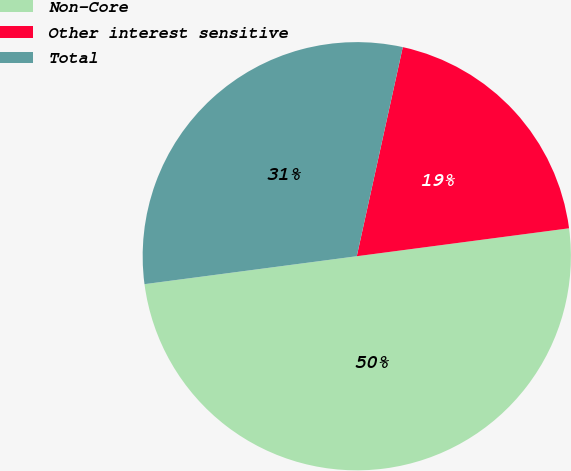Convert chart to OTSL. <chart><loc_0><loc_0><loc_500><loc_500><pie_chart><fcel>Non-Core<fcel>Other interest sensitive<fcel>Total<nl><fcel>50.0%<fcel>19.47%<fcel>30.53%<nl></chart> 